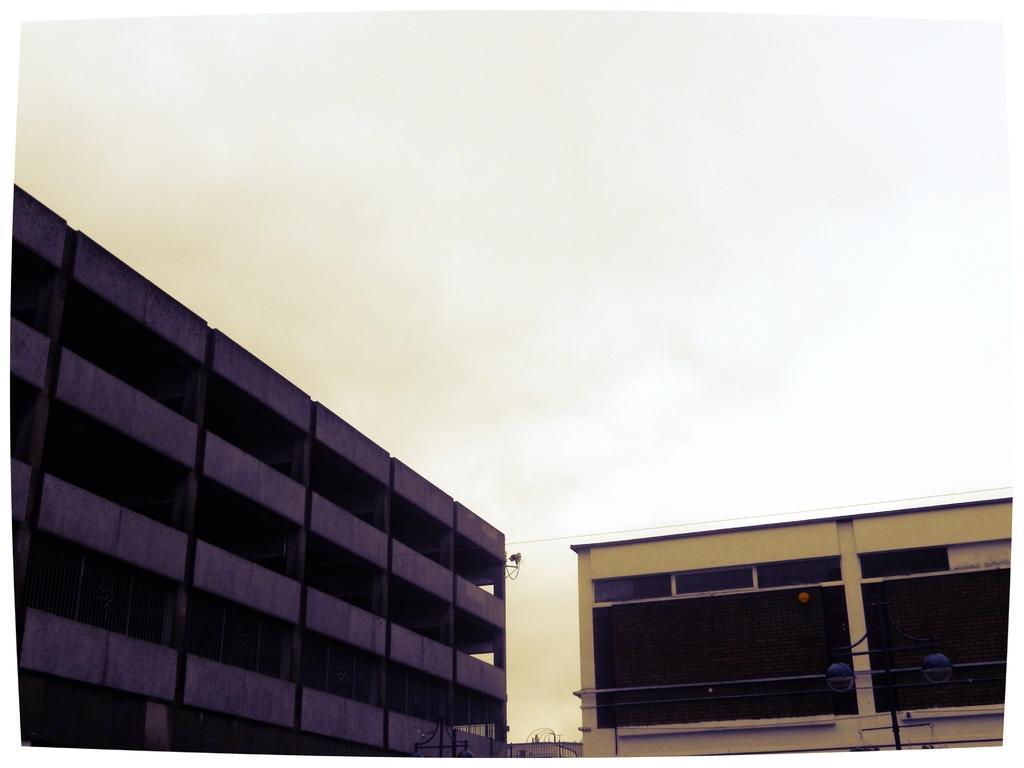How would you summarize this image in a sentence or two? There are buildings in the foreground area of the image, it seems like gates and lamp pole at the bottom side and the sky in the background. 